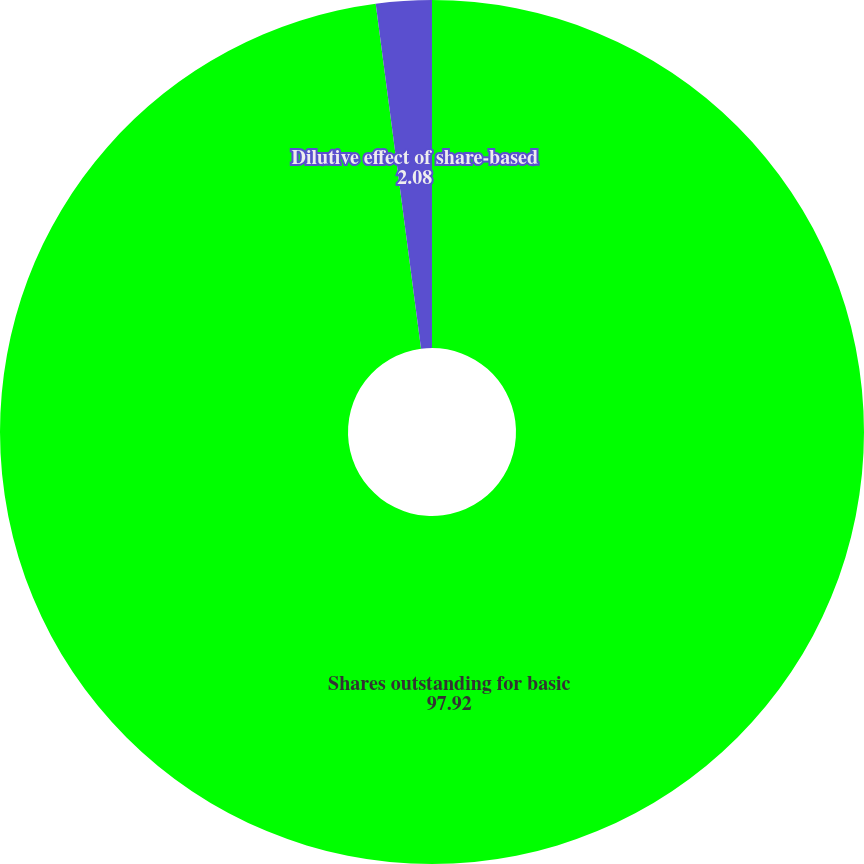Convert chart. <chart><loc_0><loc_0><loc_500><loc_500><pie_chart><fcel>Shares outstanding for basic<fcel>Dilutive effect of share-based<nl><fcel>97.92%<fcel>2.08%<nl></chart> 